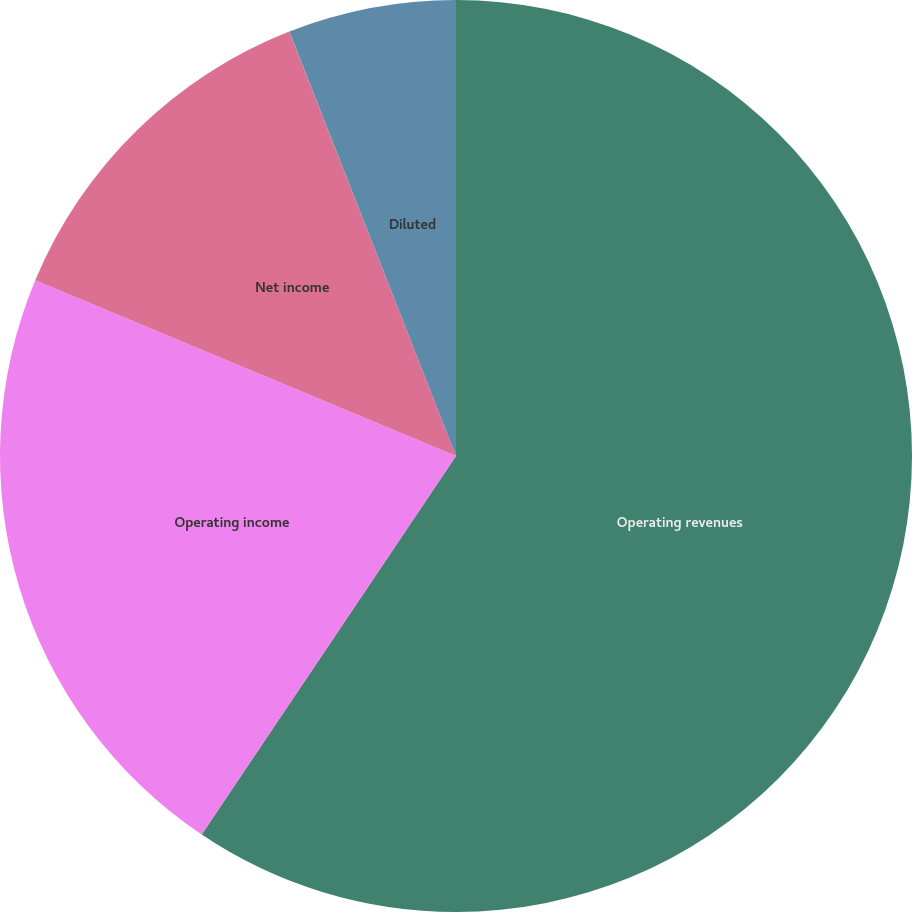Convert chart. <chart><loc_0><loc_0><loc_500><loc_500><pie_chart><fcel>Operating revenues<fcel>Operating income<fcel>Net income<fcel>Basic<fcel>Diluted<nl><fcel>59.41%<fcel>21.88%<fcel>12.74%<fcel>0.01%<fcel>5.95%<nl></chart> 